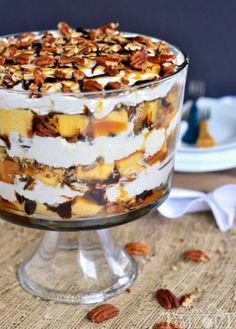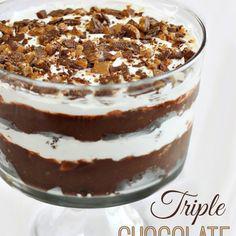The first image is the image on the left, the second image is the image on the right. For the images shown, is this caption "There is a layered dessert in a clear container that shows three layers of chocolate cake and at least three layers of cream filling." true? Answer yes or no. Yes. The first image is the image on the left, the second image is the image on the right. Considering the images on both sides, is "Both of the trifles are in glass dishes with stands." valid? Answer yes or no. Yes. 